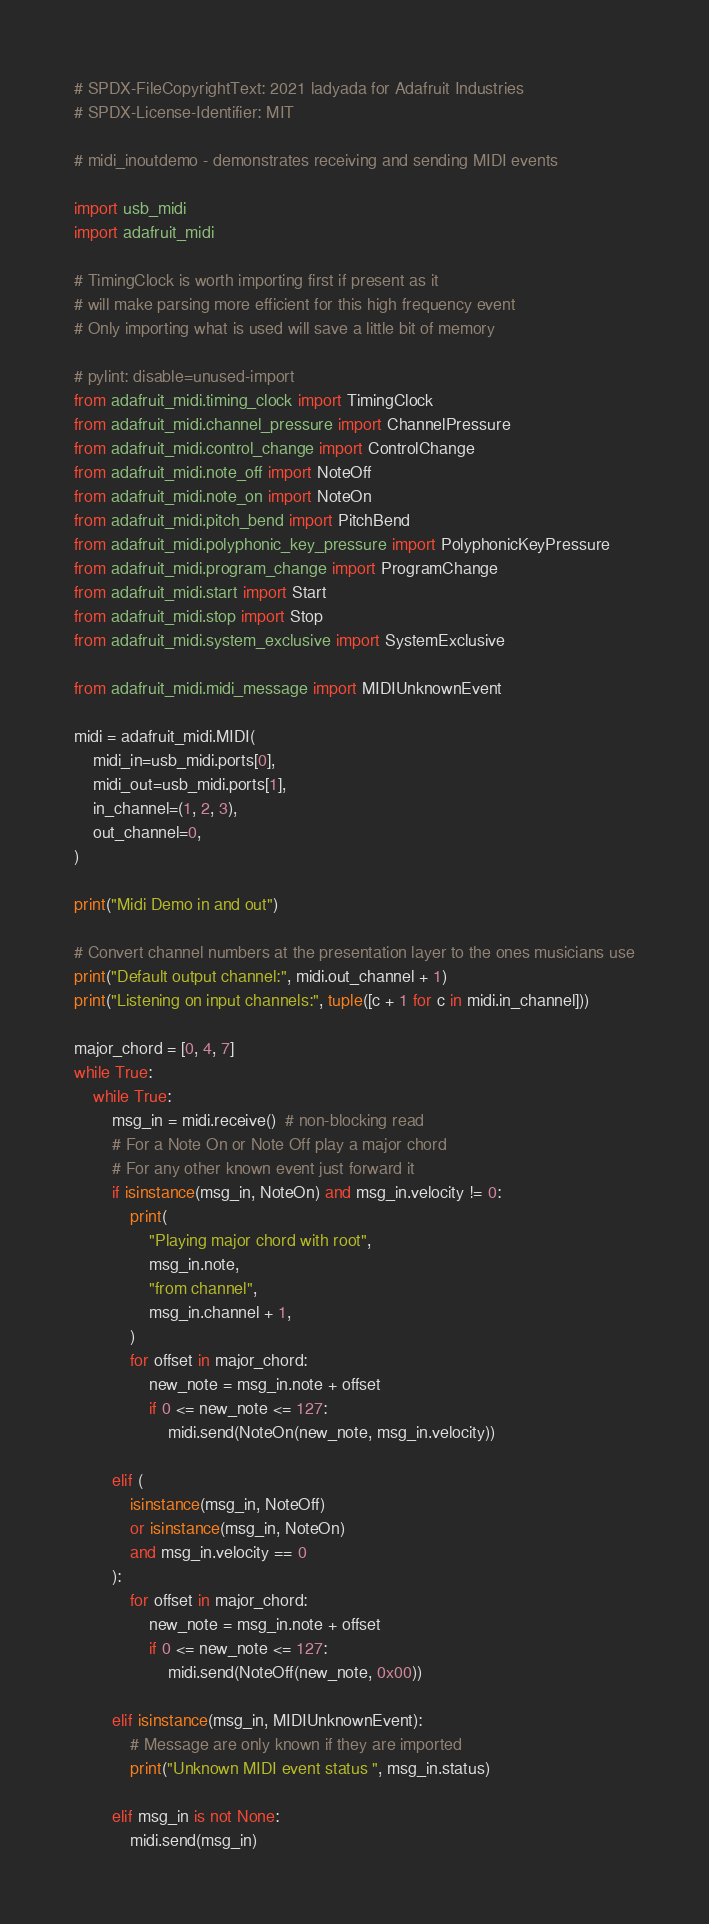Convert code to text. <code><loc_0><loc_0><loc_500><loc_500><_Python_># SPDX-FileCopyrightText: 2021 ladyada for Adafruit Industries
# SPDX-License-Identifier: MIT

# midi_inoutdemo - demonstrates receiving and sending MIDI events

import usb_midi
import adafruit_midi

# TimingClock is worth importing first if present as it
# will make parsing more efficient for this high frequency event
# Only importing what is used will save a little bit of memory

# pylint: disable=unused-import
from adafruit_midi.timing_clock import TimingClock
from adafruit_midi.channel_pressure import ChannelPressure
from adafruit_midi.control_change import ControlChange
from adafruit_midi.note_off import NoteOff
from adafruit_midi.note_on import NoteOn
from adafruit_midi.pitch_bend import PitchBend
from adafruit_midi.polyphonic_key_pressure import PolyphonicKeyPressure
from adafruit_midi.program_change import ProgramChange
from adafruit_midi.start import Start
from adafruit_midi.stop import Stop
from adafruit_midi.system_exclusive import SystemExclusive

from adafruit_midi.midi_message import MIDIUnknownEvent

midi = adafruit_midi.MIDI(
    midi_in=usb_midi.ports[0],
    midi_out=usb_midi.ports[1],
    in_channel=(1, 2, 3),
    out_channel=0,
)

print("Midi Demo in and out")

# Convert channel numbers at the presentation layer to the ones musicians use
print("Default output channel:", midi.out_channel + 1)
print("Listening on input channels:", tuple([c + 1 for c in midi.in_channel]))

major_chord = [0, 4, 7]
while True:
    while True:
        msg_in = midi.receive()  # non-blocking read
        # For a Note On or Note Off play a major chord
        # For any other known event just forward it
        if isinstance(msg_in, NoteOn) and msg_in.velocity != 0:
            print(
                "Playing major chord with root",
                msg_in.note,
                "from channel",
                msg_in.channel + 1,
            )
            for offset in major_chord:
                new_note = msg_in.note + offset
                if 0 <= new_note <= 127:
                    midi.send(NoteOn(new_note, msg_in.velocity))

        elif (
            isinstance(msg_in, NoteOff)
            or isinstance(msg_in, NoteOn)
            and msg_in.velocity == 0
        ):
            for offset in major_chord:
                new_note = msg_in.note + offset
                if 0 <= new_note <= 127:
                    midi.send(NoteOff(new_note, 0x00))

        elif isinstance(msg_in, MIDIUnknownEvent):
            # Message are only known if they are imported
            print("Unknown MIDI event status ", msg_in.status)

        elif msg_in is not None:
            midi.send(msg_in)
</code> 